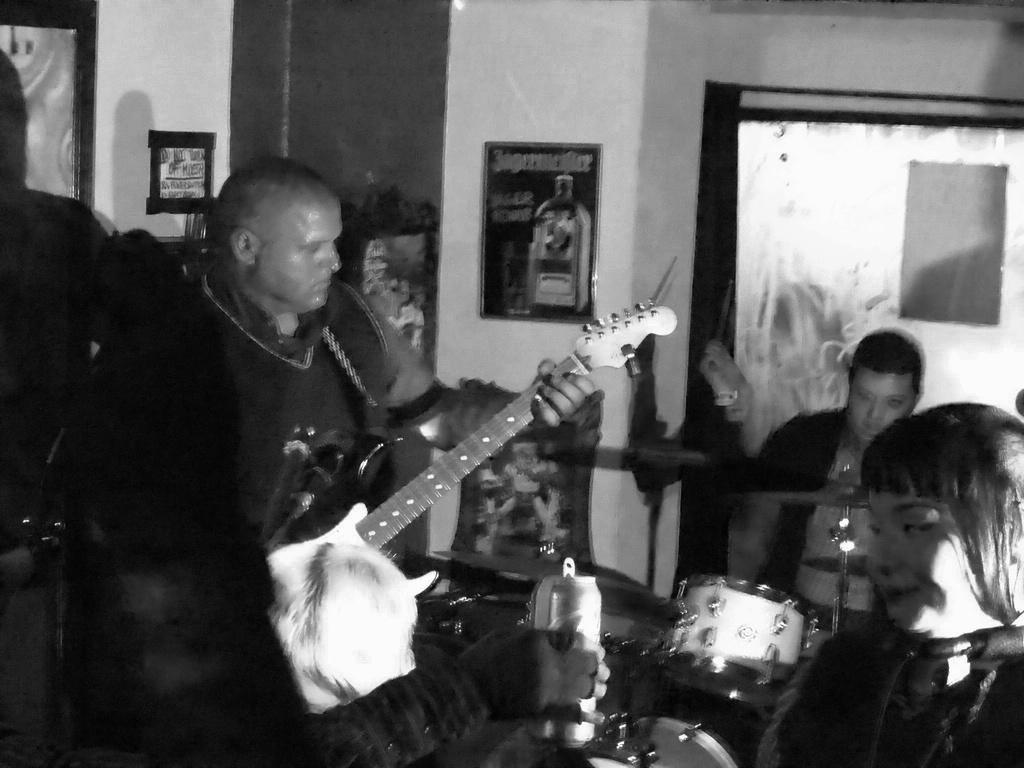Can you describe this image briefly? In this picture we see a man playing guitar and the man seated and playing drums. 